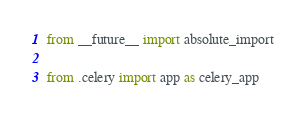<code> <loc_0><loc_0><loc_500><loc_500><_Python_>from __future__ import absolute_import

from .celery import app as celery_app

</code> 